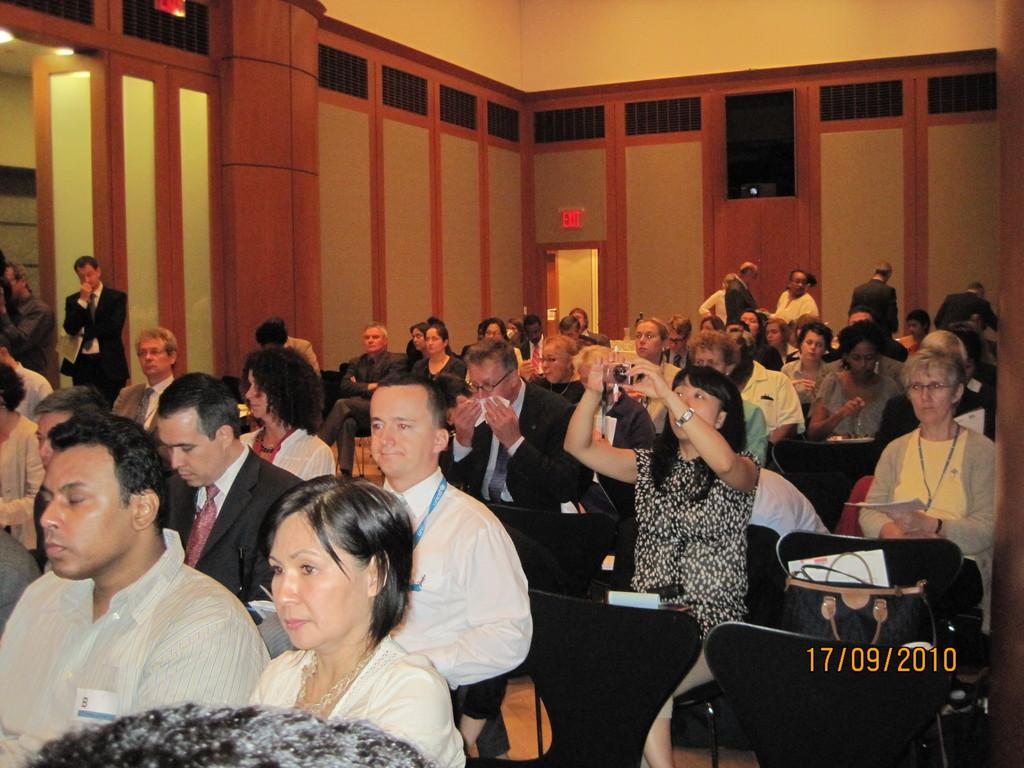What are the people in the image doing? The people in the image are sitting on chairs. What can be seen at the right side of the image? There is a bag at the right side of the image. What is the person at the left side of the image doing? There is a person standing at the left side of the image. What might the person holding the camera be doing? The person holding the camera might be taking a picture. What type of yarn is the person holding in the image? There is no yarn present in the image; the person is holding a camera. What flavor of soda is the person drinking in the image? There is no soda present in the image; the focus is on the people, chairs, bag, and camera. 